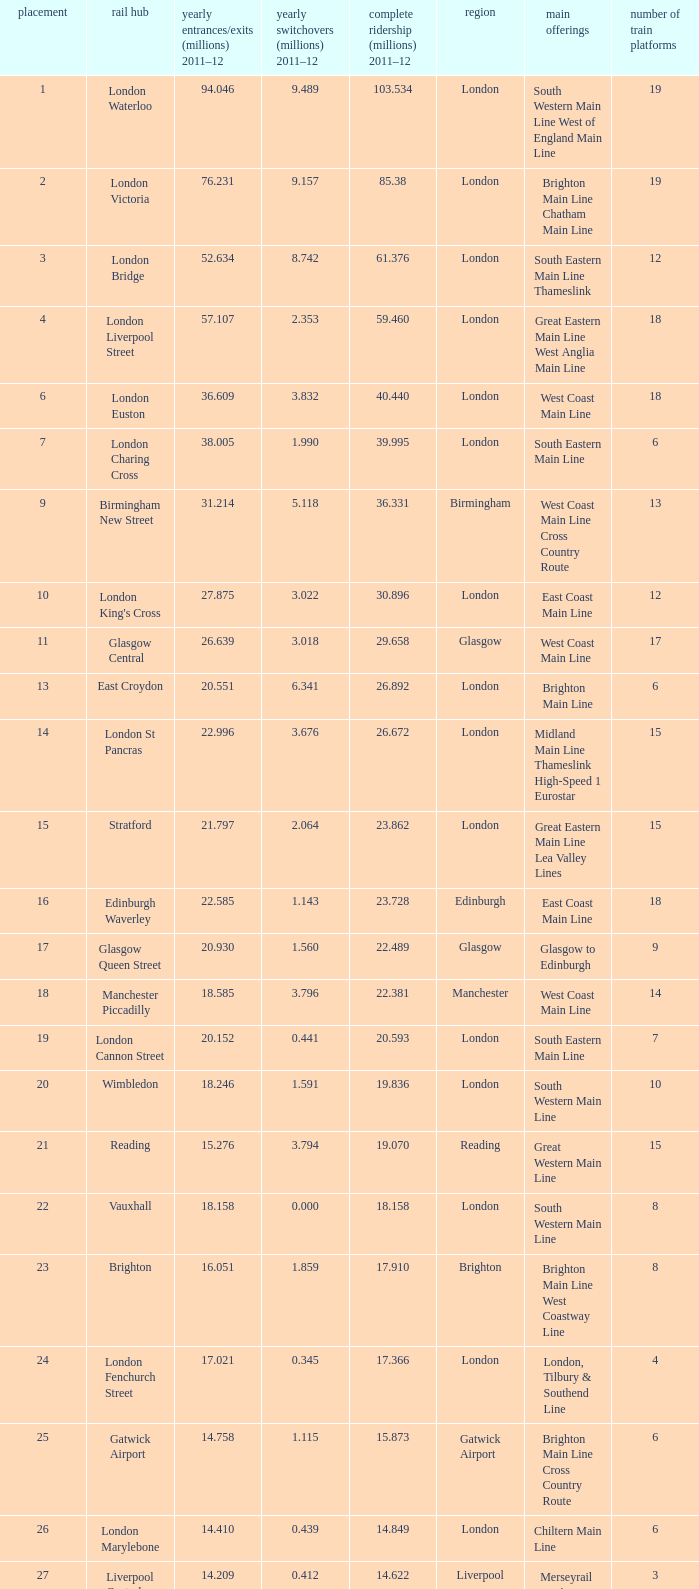Which location has 103.534 million passengers in 2011-12?  London. 